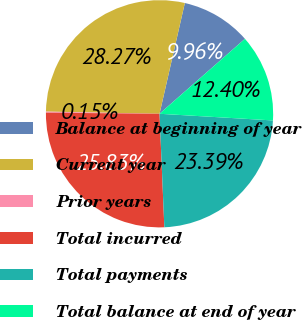<chart> <loc_0><loc_0><loc_500><loc_500><pie_chart><fcel>Balance at beginning of year<fcel>Current year<fcel>Prior years<fcel>Total incurred<fcel>Total payments<fcel>Total balance at end of year<nl><fcel>9.96%<fcel>28.27%<fcel>0.15%<fcel>25.83%<fcel>23.39%<fcel>12.4%<nl></chart> 